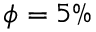<formula> <loc_0><loc_0><loc_500><loc_500>\phi = 5 \%</formula> 